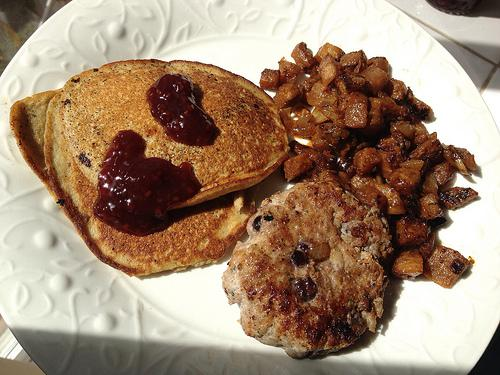Question: how many pancakes are there?
Choices:
A. Four.
B. Three.
C. Five.
D. Two.
Answer with the letter. Answer: B Question: what color are the pancakes?
Choices:
A. Brown.
B. Yellow.
C. Golden.
D. Red.
Answer with the letter. Answer: A Question: how are the pancakes arranged?
Choices:
A. In a pile.
B. In a stack.
C. On the plate.
D. In the pan.
Answer with the letter. Answer: A Question: what is in the decoration on the side of the plate?
Choices:
A. Chocolate Sauce.
B. Swirl Pattern.
C. Leaves.
D. Monogram.
Answer with the letter. Answer: C Question: how many dollops of jam are there?
Choices:
A. Two.
B. Three.
C. One.
D. Four.
Answer with the letter. Answer: A 